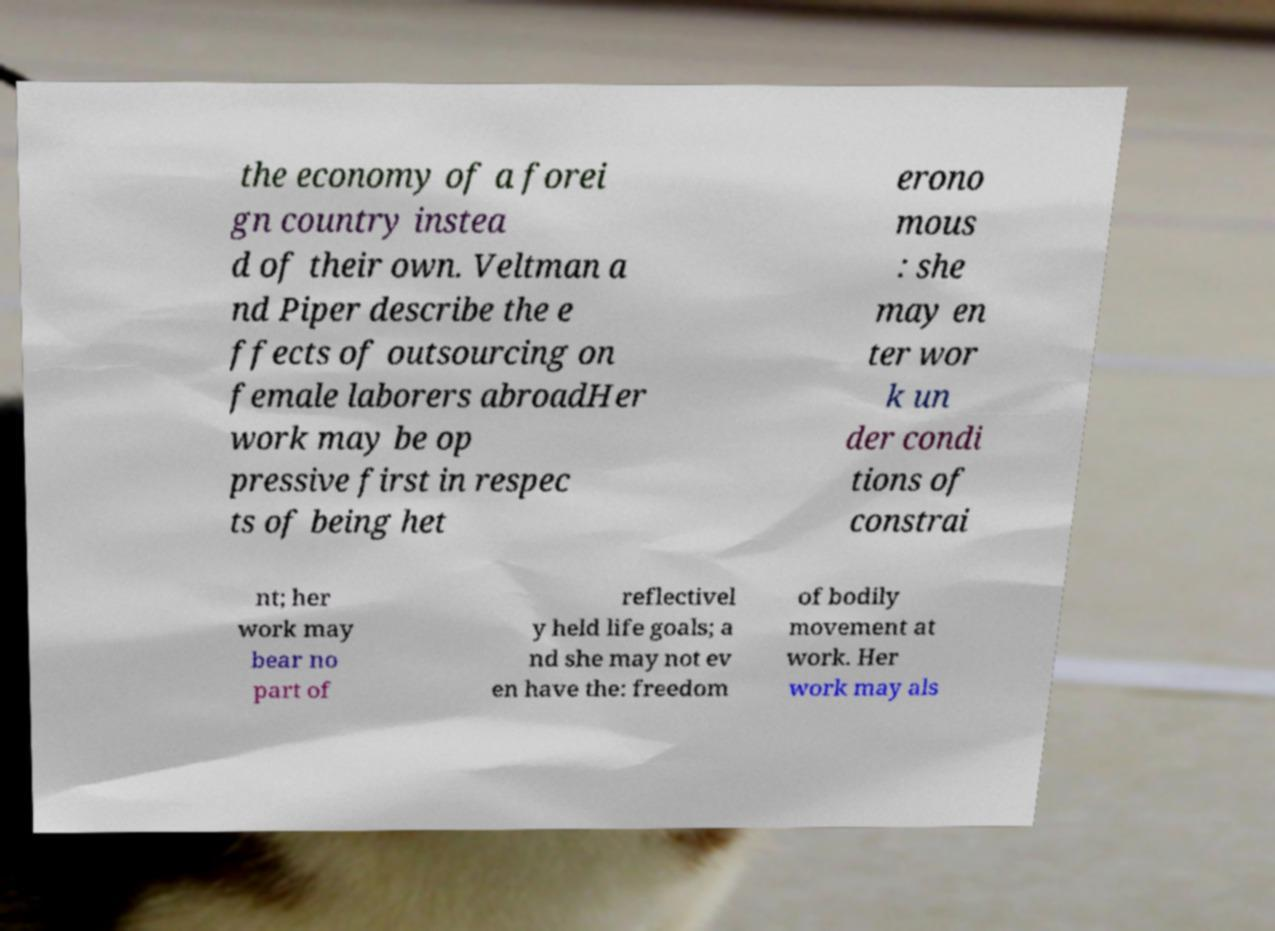What messages or text are displayed in this image? I need them in a readable, typed format. the economy of a forei gn country instea d of their own. Veltman a nd Piper describe the e ffects of outsourcing on female laborers abroadHer work may be op pressive first in respec ts of being het erono mous : she may en ter wor k un der condi tions of constrai nt; her work may bear no part of reflectivel y held life goals; a nd she may not ev en have the: freedom of bodily movement at work. Her work may als 